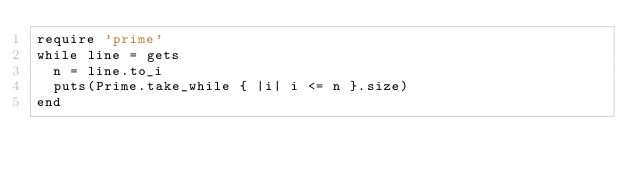<code> <loc_0><loc_0><loc_500><loc_500><_Ruby_>require 'prime'
while line = gets
  n = line.to_i
  puts(Prime.take_while { |i| i <= n }.size)
end
</code> 